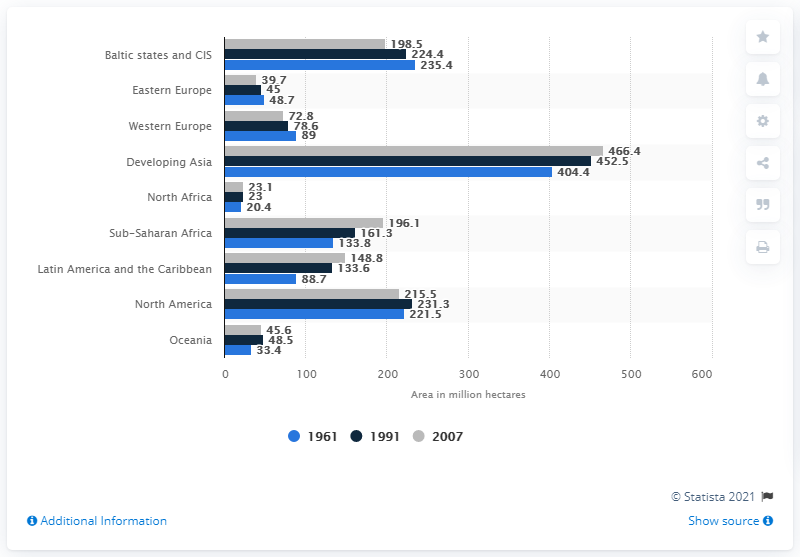Identify some key points in this picture. In 1961, arable land was available in the Baltic States and the Commonwealth of Independent States, with a total of 235.4 million hectares. 